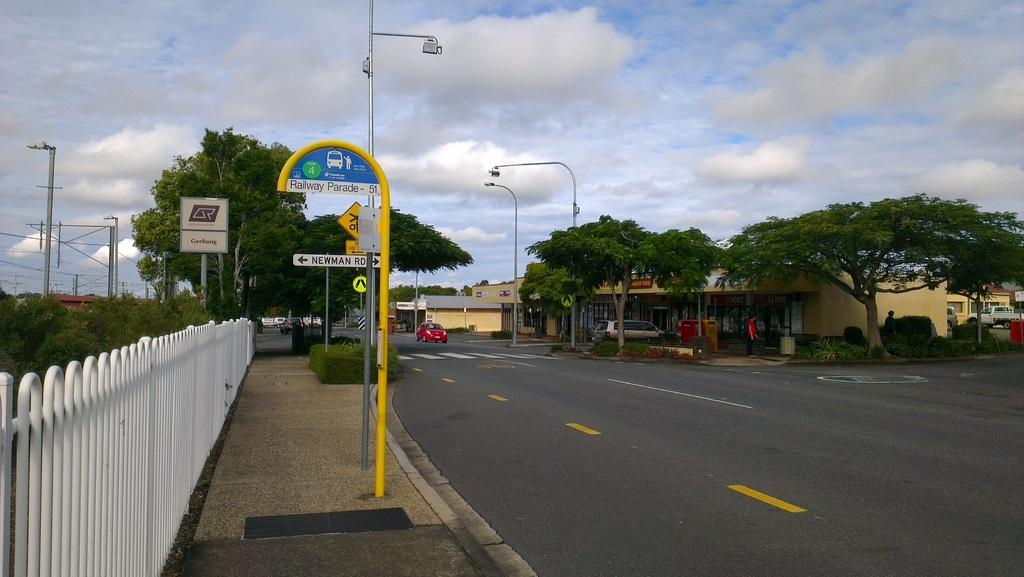<image>
Describe the image concisely. A bus stop with the sign "Railway Parade." sits across the street from a small store. 